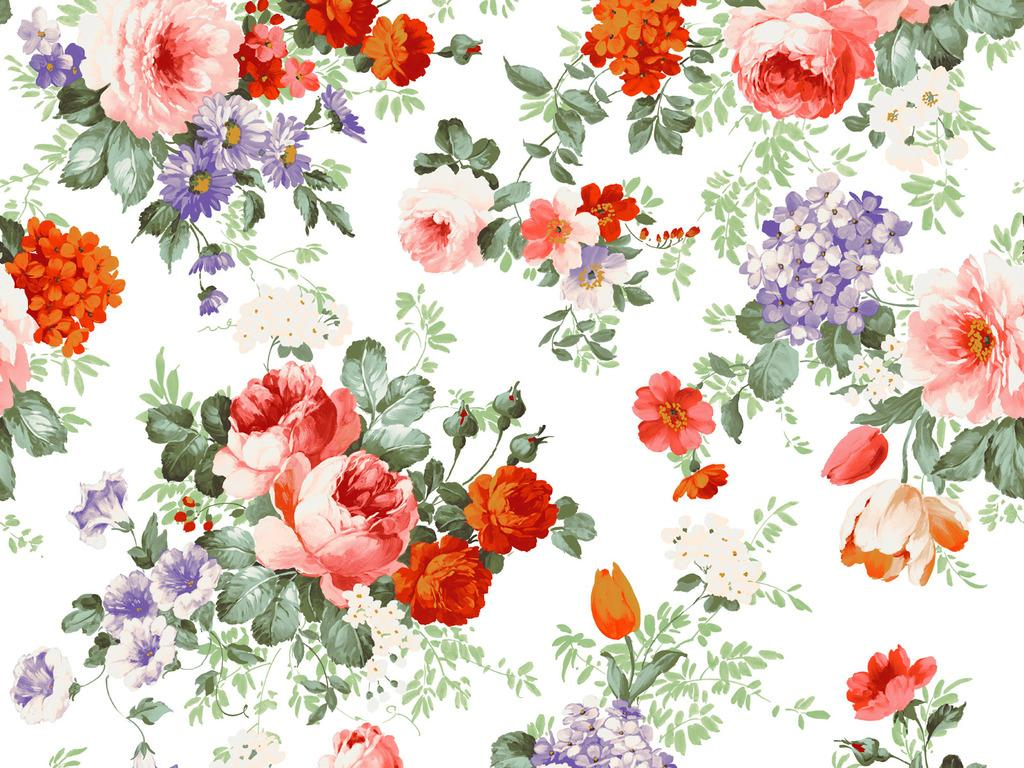What type of plants are depicted in the image? The image contains a depiction of flowers and leaves. What colors are the flowers in the image? The colors of the flowers include pink, red, and purple. Can you tell me how many goats are grazing on the edge of the image? There are no goats present in the image. What type of bead is used to decorate the flowers in the image? There is no mention of beads being used to decorate the flowers in the image. 